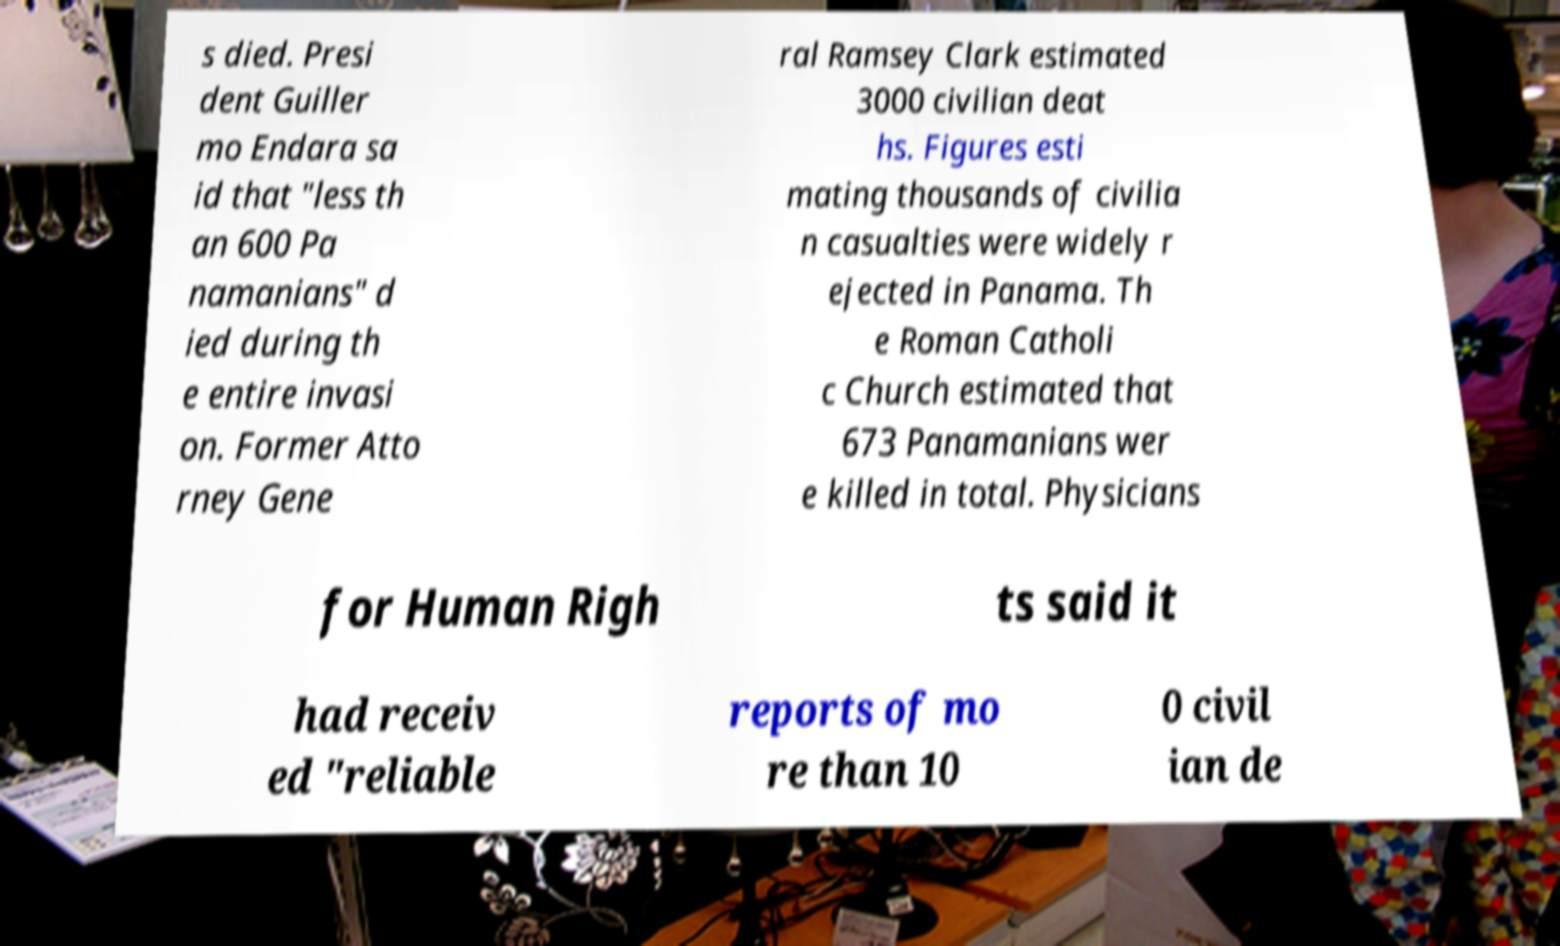Please identify and transcribe the text found in this image. s died. Presi dent Guiller mo Endara sa id that "less th an 600 Pa namanians" d ied during th e entire invasi on. Former Atto rney Gene ral Ramsey Clark estimated 3000 civilian deat hs. Figures esti mating thousands of civilia n casualties were widely r ejected in Panama. Th e Roman Catholi c Church estimated that 673 Panamanians wer e killed in total. Physicians for Human Righ ts said it had receiv ed "reliable reports of mo re than 10 0 civil ian de 